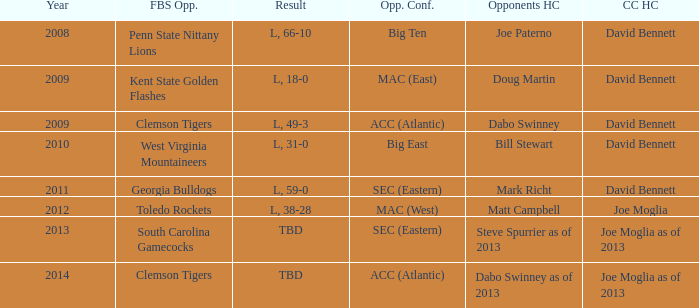Who was the coastal Carolina head coach in 2013? Joe Moglia as of 2013. 